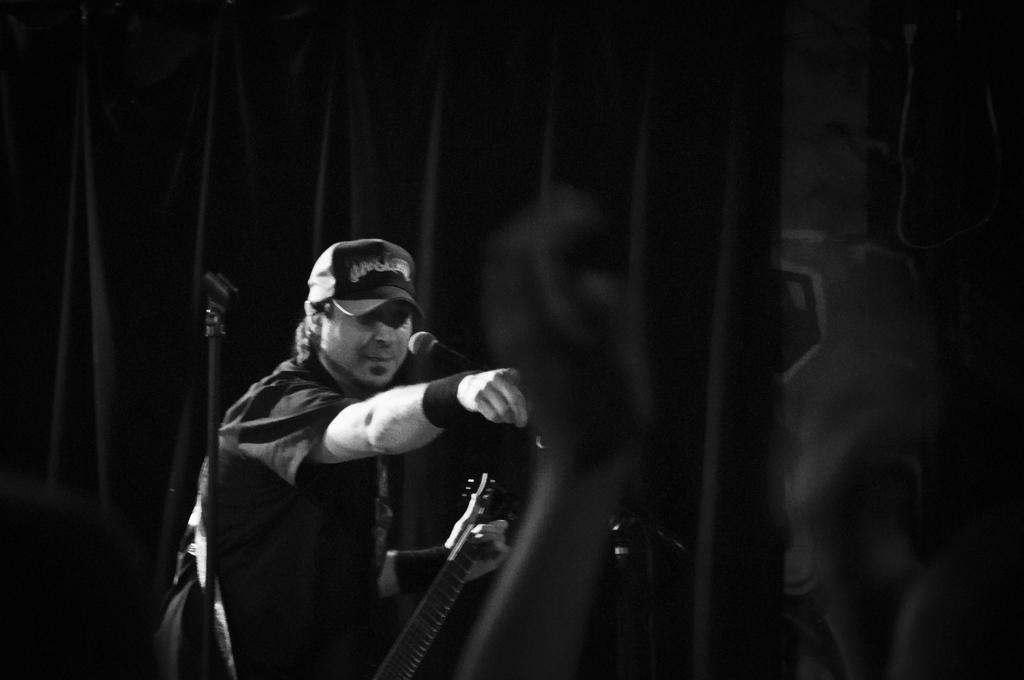Please provide a concise description of this image. This is a black and white image. On the left side there is a man wearing a shirt, cap on the head, standing and holding a guitar in the hand. In front of this man there is a mike stand. In the background there is a curtain. 